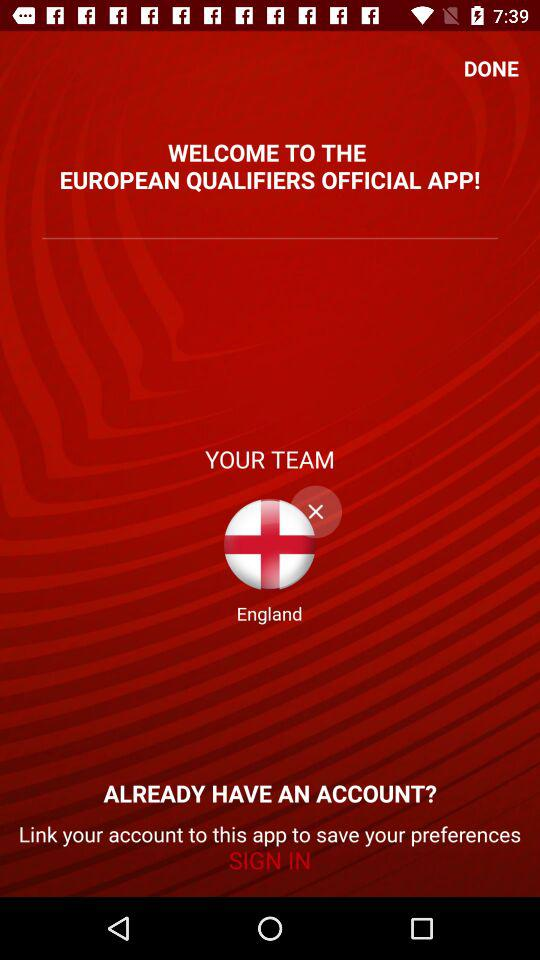What is the name of the application? The name of the application is "EUROPEAN QUALIFIERS". 